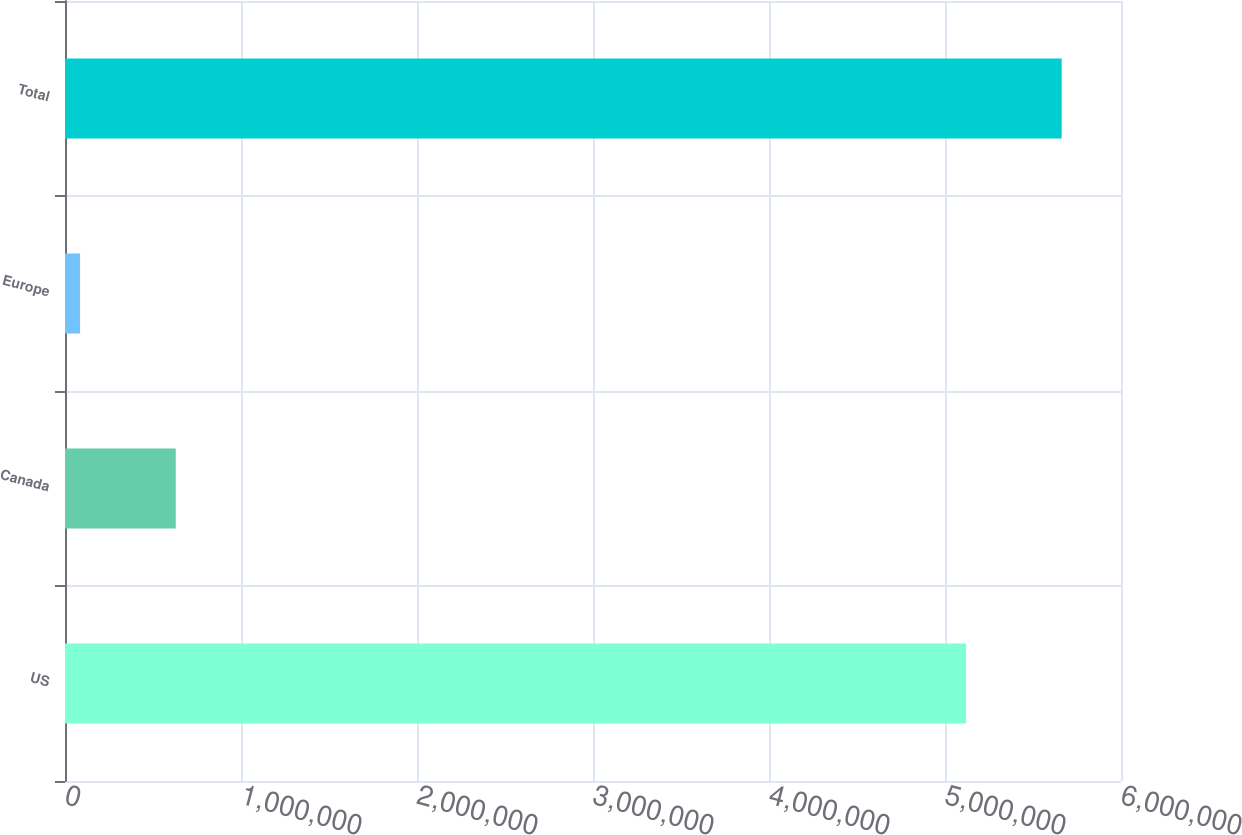Convert chart. <chart><loc_0><loc_0><loc_500><loc_500><bar_chart><fcel>US<fcel>Canada<fcel>Europe<fcel>Total<nl><fcel>5.11954e+06<fcel>629258<fcel>85718<fcel>5.66308e+06<nl></chart> 